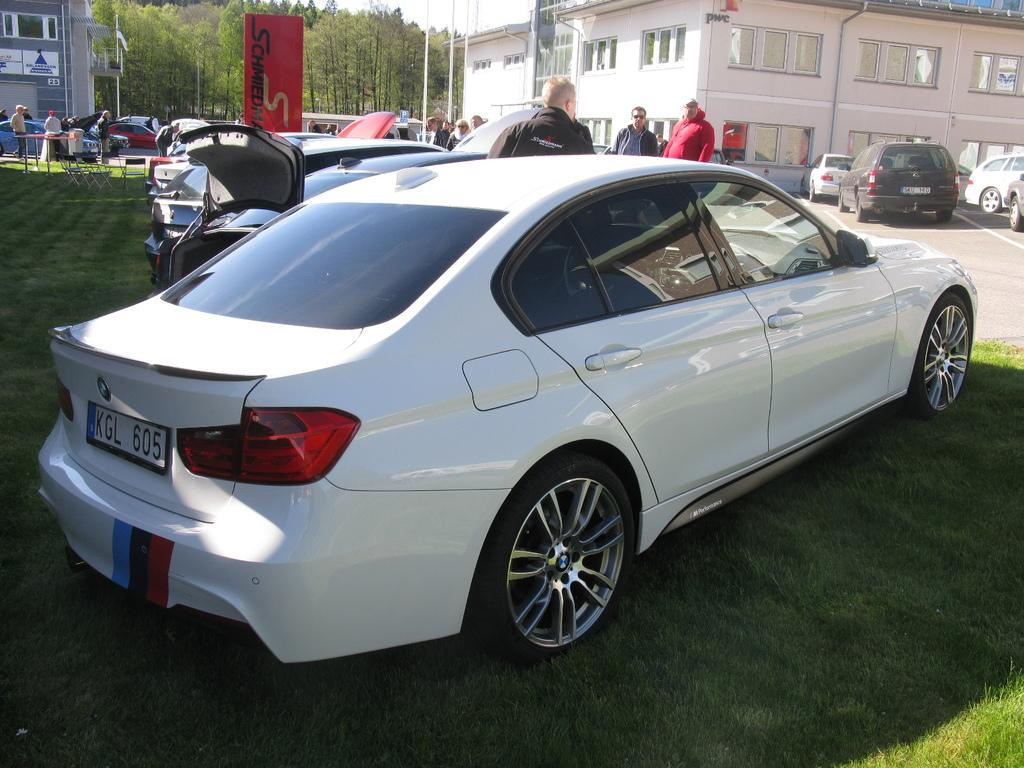What type of vehicles can be seen in the image? There are cars in the image. What structures are present in the image? There are poles, buildings, and trees in the image. Are there any living beings in the image? Yes, there are people in the image. Can you tell me how many dolls are present in the image? There are no dolls present in the image. What type of birth is depicted in the image? There is no birth depicted in the image. 